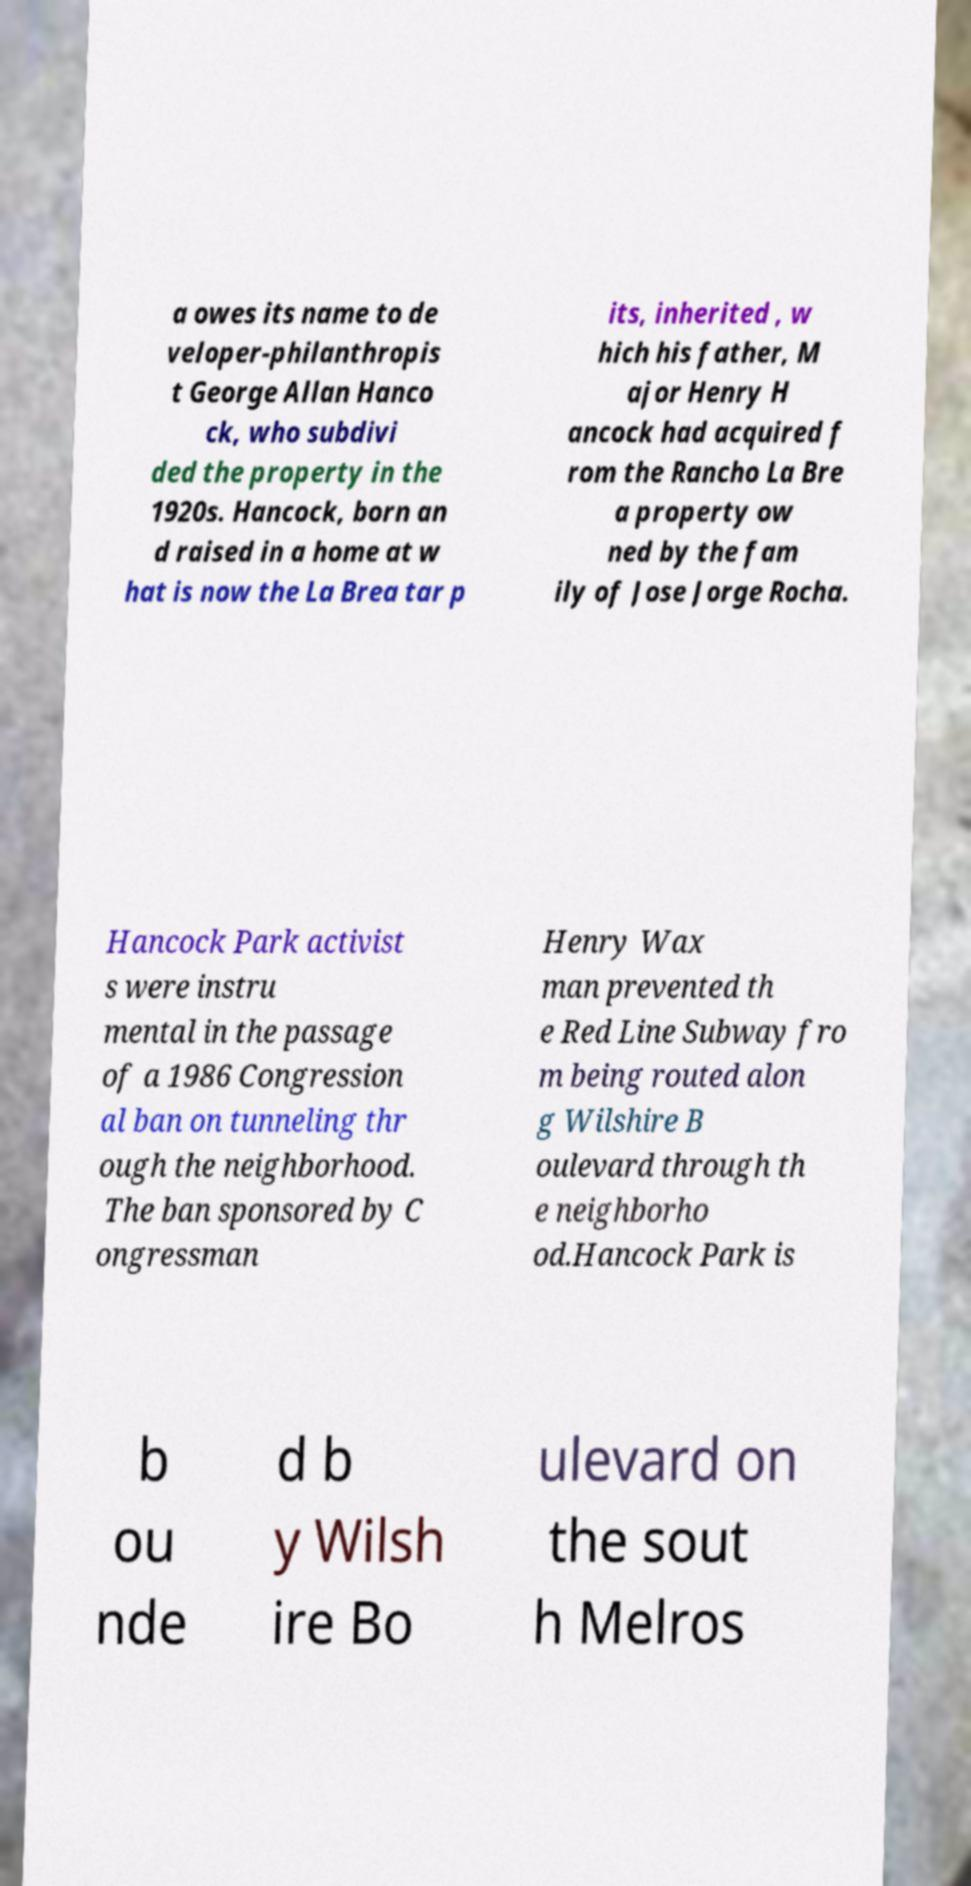There's text embedded in this image that I need extracted. Can you transcribe it verbatim? a owes its name to de veloper-philanthropis t George Allan Hanco ck, who subdivi ded the property in the 1920s. Hancock, born an d raised in a home at w hat is now the La Brea tar p its, inherited , w hich his father, M ajor Henry H ancock had acquired f rom the Rancho La Bre a property ow ned by the fam ily of Jose Jorge Rocha. Hancock Park activist s were instru mental in the passage of a 1986 Congression al ban on tunneling thr ough the neighborhood. The ban sponsored by C ongressman Henry Wax man prevented th e Red Line Subway fro m being routed alon g Wilshire B oulevard through th e neighborho od.Hancock Park is b ou nde d b y Wilsh ire Bo ulevard on the sout h Melros 